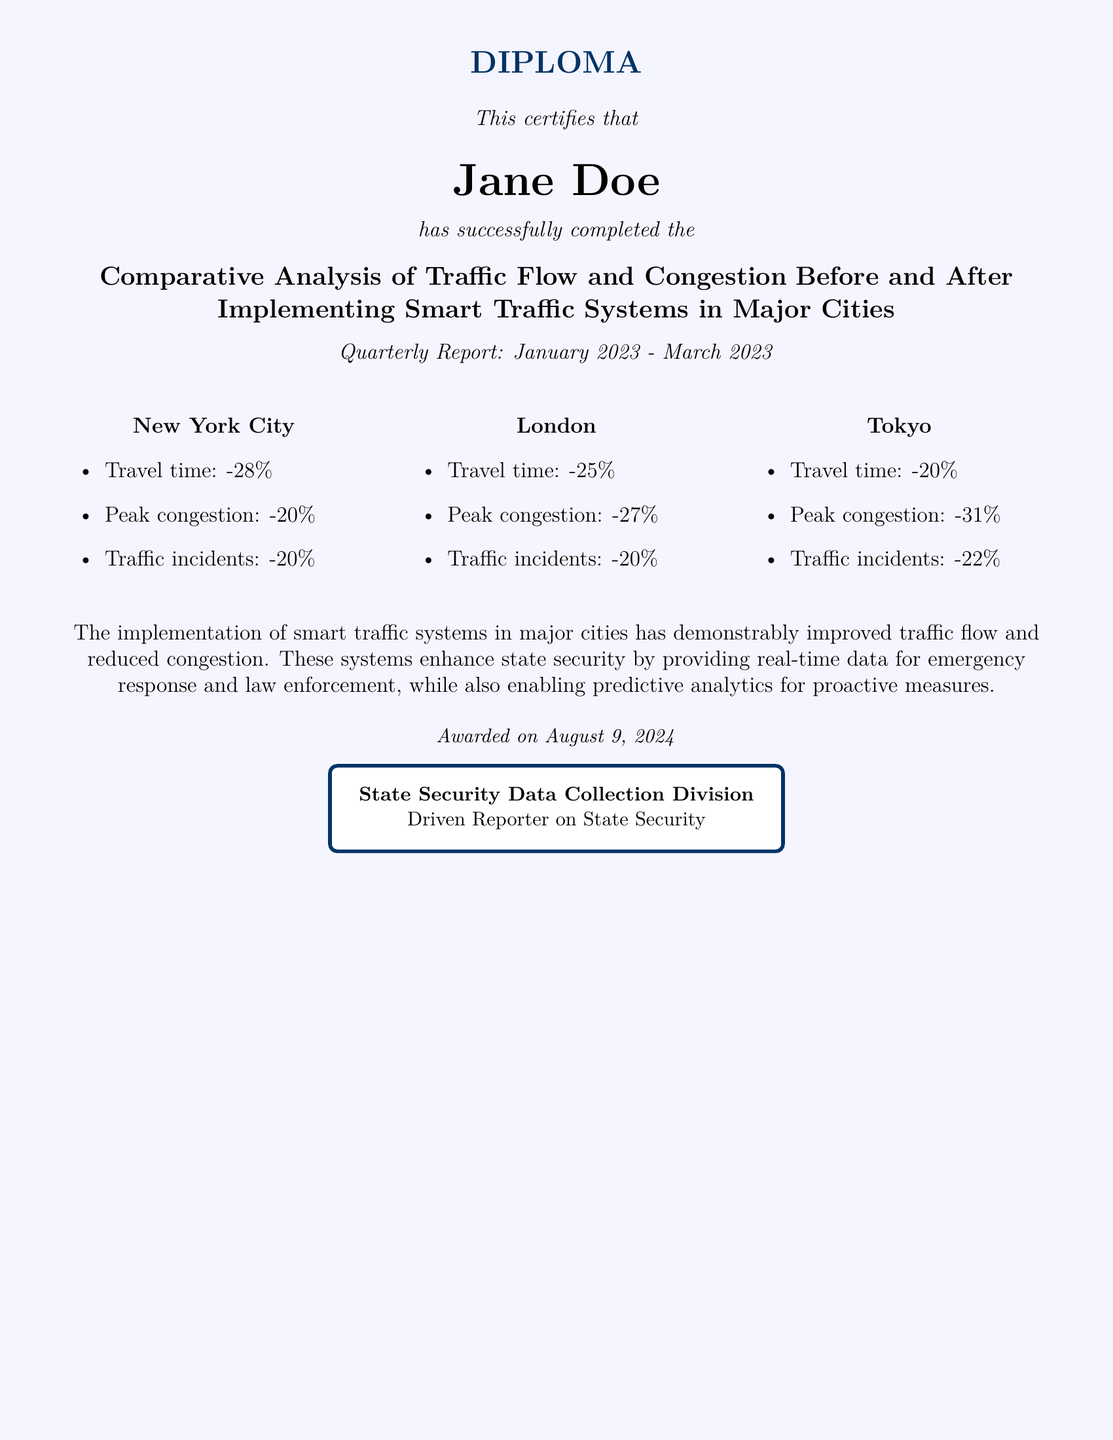what is the name of the recipient? The recipient of the diploma is mentioned at the top of the document as "Jane Doe."
Answer: Jane Doe what is the title of the report? The title specifies the focus of the analysis conducted by Jane Doe, which is about traffic flow and congestion.
Answer: Comparative Analysis of Traffic Flow and Congestion Before and After Implementing Smart Traffic Systems in Major Cities what is the percentage reduction in travel time in New York City? The document states the travel time reduction in New York City as seen in the bullet points.
Answer: -28% what month and year does the report cover? The diploma explicitly states the reporting period at the bottom, which is from January to March 2023.
Answer: January 2023 - March 2023 which city had the highest reduction in peak congestion? By comparing the percentages of peak congestion reductions across the cities, it can be determined which city experienced the most significant decrease.
Answer: Tokyo how many cities are analyzed in the report? The document lists three major cities that are analyzed regarding traffic flow and congestion changes.
Answer: Three which organization awarded this diploma? The awarding organization is mentioned at the end of the document in a designated section.
Answer: State Security Data Collection Division what is the overall impact of smart traffic systems as stated in the document? The document summarizes the benefits of smart traffic systems that enhance both traffic flow and state security.
Answer: Improved traffic flow and reduced congestion 